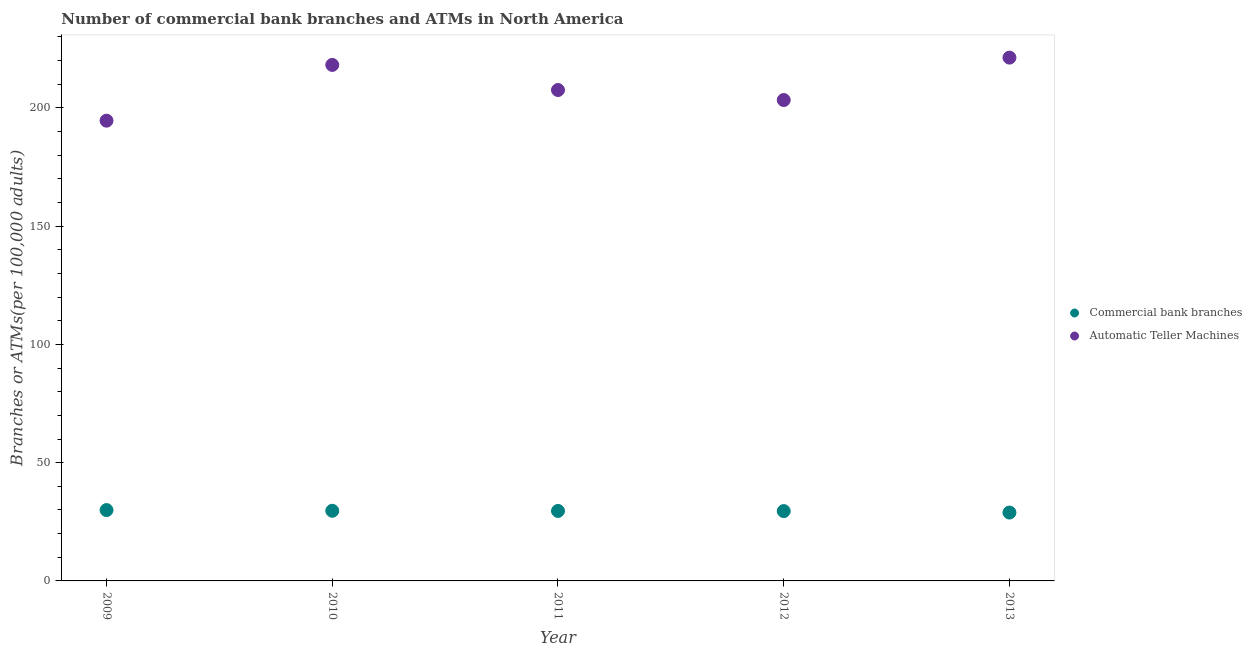What is the number of commercal bank branches in 2011?
Give a very brief answer. 29.59. Across all years, what is the maximum number of atms?
Make the answer very short. 221.26. Across all years, what is the minimum number of commercal bank branches?
Your response must be concise. 28.9. What is the total number of commercal bank branches in the graph?
Your response must be concise. 147.63. What is the difference between the number of commercal bank branches in 2009 and that in 2011?
Give a very brief answer. 0.36. What is the difference between the number of atms in 2013 and the number of commercal bank branches in 2009?
Make the answer very short. 191.31. What is the average number of commercal bank branches per year?
Make the answer very short. 29.53. In the year 2009, what is the difference between the number of atms and number of commercal bank branches?
Make the answer very short. 164.65. In how many years, is the number of commercal bank branches greater than 170?
Give a very brief answer. 0. What is the ratio of the number of atms in 2009 to that in 2011?
Provide a short and direct response. 0.94. Is the number of commercal bank branches in 2010 less than that in 2013?
Ensure brevity in your answer.  No. What is the difference between the highest and the second highest number of atms?
Make the answer very short. 3.08. What is the difference between the highest and the lowest number of atms?
Your answer should be very brief. 26.66. Is the number of atms strictly greater than the number of commercal bank branches over the years?
Keep it short and to the point. Yes. Is the number of commercal bank branches strictly less than the number of atms over the years?
Give a very brief answer. Yes. How many years are there in the graph?
Give a very brief answer. 5. What is the difference between two consecutive major ticks on the Y-axis?
Give a very brief answer. 50. Are the values on the major ticks of Y-axis written in scientific E-notation?
Your answer should be compact. No. Does the graph contain any zero values?
Your answer should be very brief. No. Where does the legend appear in the graph?
Give a very brief answer. Center right. How are the legend labels stacked?
Ensure brevity in your answer.  Vertical. What is the title of the graph?
Your answer should be compact. Number of commercial bank branches and ATMs in North America. What is the label or title of the X-axis?
Your answer should be very brief. Year. What is the label or title of the Y-axis?
Make the answer very short. Branches or ATMs(per 100,0 adults). What is the Branches or ATMs(per 100,000 adults) of Commercial bank branches in 2009?
Ensure brevity in your answer.  29.95. What is the Branches or ATMs(per 100,000 adults) in Automatic Teller Machines in 2009?
Give a very brief answer. 194.6. What is the Branches or ATMs(per 100,000 adults) of Commercial bank branches in 2010?
Your response must be concise. 29.65. What is the Branches or ATMs(per 100,000 adults) of Automatic Teller Machines in 2010?
Ensure brevity in your answer.  218.18. What is the Branches or ATMs(per 100,000 adults) in Commercial bank branches in 2011?
Provide a short and direct response. 29.59. What is the Branches or ATMs(per 100,000 adults) of Automatic Teller Machines in 2011?
Your response must be concise. 207.56. What is the Branches or ATMs(per 100,000 adults) of Commercial bank branches in 2012?
Ensure brevity in your answer.  29.53. What is the Branches or ATMs(per 100,000 adults) of Automatic Teller Machines in 2012?
Keep it short and to the point. 203.33. What is the Branches or ATMs(per 100,000 adults) in Commercial bank branches in 2013?
Provide a short and direct response. 28.9. What is the Branches or ATMs(per 100,000 adults) of Automatic Teller Machines in 2013?
Provide a succinct answer. 221.26. Across all years, what is the maximum Branches or ATMs(per 100,000 adults) of Commercial bank branches?
Ensure brevity in your answer.  29.95. Across all years, what is the maximum Branches or ATMs(per 100,000 adults) in Automatic Teller Machines?
Keep it short and to the point. 221.26. Across all years, what is the minimum Branches or ATMs(per 100,000 adults) of Commercial bank branches?
Give a very brief answer. 28.9. Across all years, what is the minimum Branches or ATMs(per 100,000 adults) of Automatic Teller Machines?
Give a very brief answer. 194.6. What is the total Branches or ATMs(per 100,000 adults) of Commercial bank branches in the graph?
Give a very brief answer. 147.63. What is the total Branches or ATMs(per 100,000 adults) of Automatic Teller Machines in the graph?
Make the answer very short. 1044.92. What is the difference between the Branches or ATMs(per 100,000 adults) in Commercial bank branches in 2009 and that in 2010?
Offer a very short reply. 0.3. What is the difference between the Branches or ATMs(per 100,000 adults) of Automatic Teller Machines in 2009 and that in 2010?
Give a very brief answer. -23.58. What is the difference between the Branches or ATMs(per 100,000 adults) of Commercial bank branches in 2009 and that in 2011?
Provide a succinct answer. 0.36. What is the difference between the Branches or ATMs(per 100,000 adults) of Automatic Teller Machines in 2009 and that in 2011?
Provide a short and direct response. -12.96. What is the difference between the Branches or ATMs(per 100,000 adults) of Commercial bank branches in 2009 and that in 2012?
Your answer should be compact. 0.43. What is the difference between the Branches or ATMs(per 100,000 adults) in Automatic Teller Machines in 2009 and that in 2012?
Keep it short and to the point. -8.73. What is the difference between the Branches or ATMs(per 100,000 adults) in Commercial bank branches in 2009 and that in 2013?
Your answer should be compact. 1.05. What is the difference between the Branches or ATMs(per 100,000 adults) in Automatic Teller Machines in 2009 and that in 2013?
Ensure brevity in your answer.  -26.66. What is the difference between the Branches or ATMs(per 100,000 adults) of Commercial bank branches in 2010 and that in 2011?
Offer a very short reply. 0.06. What is the difference between the Branches or ATMs(per 100,000 adults) of Automatic Teller Machines in 2010 and that in 2011?
Make the answer very short. 10.61. What is the difference between the Branches or ATMs(per 100,000 adults) of Commercial bank branches in 2010 and that in 2012?
Your response must be concise. 0.13. What is the difference between the Branches or ATMs(per 100,000 adults) in Automatic Teller Machines in 2010 and that in 2012?
Keep it short and to the point. 14.85. What is the difference between the Branches or ATMs(per 100,000 adults) of Commercial bank branches in 2010 and that in 2013?
Ensure brevity in your answer.  0.75. What is the difference between the Branches or ATMs(per 100,000 adults) of Automatic Teller Machines in 2010 and that in 2013?
Provide a succinct answer. -3.08. What is the difference between the Branches or ATMs(per 100,000 adults) in Commercial bank branches in 2011 and that in 2012?
Your answer should be compact. 0.06. What is the difference between the Branches or ATMs(per 100,000 adults) in Automatic Teller Machines in 2011 and that in 2012?
Keep it short and to the point. 4.24. What is the difference between the Branches or ATMs(per 100,000 adults) of Commercial bank branches in 2011 and that in 2013?
Offer a terse response. 0.69. What is the difference between the Branches or ATMs(per 100,000 adults) of Automatic Teller Machines in 2011 and that in 2013?
Make the answer very short. -13.7. What is the difference between the Branches or ATMs(per 100,000 adults) in Commercial bank branches in 2012 and that in 2013?
Provide a succinct answer. 0.63. What is the difference between the Branches or ATMs(per 100,000 adults) of Automatic Teller Machines in 2012 and that in 2013?
Give a very brief answer. -17.93. What is the difference between the Branches or ATMs(per 100,000 adults) of Commercial bank branches in 2009 and the Branches or ATMs(per 100,000 adults) of Automatic Teller Machines in 2010?
Provide a short and direct response. -188.22. What is the difference between the Branches or ATMs(per 100,000 adults) of Commercial bank branches in 2009 and the Branches or ATMs(per 100,000 adults) of Automatic Teller Machines in 2011?
Keep it short and to the point. -177.61. What is the difference between the Branches or ATMs(per 100,000 adults) in Commercial bank branches in 2009 and the Branches or ATMs(per 100,000 adults) in Automatic Teller Machines in 2012?
Your answer should be very brief. -173.37. What is the difference between the Branches or ATMs(per 100,000 adults) in Commercial bank branches in 2009 and the Branches or ATMs(per 100,000 adults) in Automatic Teller Machines in 2013?
Give a very brief answer. -191.31. What is the difference between the Branches or ATMs(per 100,000 adults) in Commercial bank branches in 2010 and the Branches or ATMs(per 100,000 adults) in Automatic Teller Machines in 2011?
Provide a succinct answer. -177.91. What is the difference between the Branches or ATMs(per 100,000 adults) of Commercial bank branches in 2010 and the Branches or ATMs(per 100,000 adults) of Automatic Teller Machines in 2012?
Give a very brief answer. -173.67. What is the difference between the Branches or ATMs(per 100,000 adults) of Commercial bank branches in 2010 and the Branches or ATMs(per 100,000 adults) of Automatic Teller Machines in 2013?
Provide a succinct answer. -191.61. What is the difference between the Branches or ATMs(per 100,000 adults) in Commercial bank branches in 2011 and the Branches or ATMs(per 100,000 adults) in Automatic Teller Machines in 2012?
Give a very brief answer. -173.74. What is the difference between the Branches or ATMs(per 100,000 adults) of Commercial bank branches in 2011 and the Branches or ATMs(per 100,000 adults) of Automatic Teller Machines in 2013?
Ensure brevity in your answer.  -191.67. What is the difference between the Branches or ATMs(per 100,000 adults) of Commercial bank branches in 2012 and the Branches or ATMs(per 100,000 adults) of Automatic Teller Machines in 2013?
Your response must be concise. -191.73. What is the average Branches or ATMs(per 100,000 adults) in Commercial bank branches per year?
Give a very brief answer. 29.53. What is the average Branches or ATMs(per 100,000 adults) in Automatic Teller Machines per year?
Your answer should be very brief. 208.98. In the year 2009, what is the difference between the Branches or ATMs(per 100,000 adults) in Commercial bank branches and Branches or ATMs(per 100,000 adults) in Automatic Teller Machines?
Provide a short and direct response. -164.65. In the year 2010, what is the difference between the Branches or ATMs(per 100,000 adults) in Commercial bank branches and Branches or ATMs(per 100,000 adults) in Automatic Teller Machines?
Give a very brief answer. -188.52. In the year 2011, what is the difference between the Branches or ATMs(per 100,000 adults) of Commercial bank branches and Branches or ATMs(per 100,000 adults) of Automatic Teller Machines?
Offer a very short reply. -177.97. In the year 2012, what is the difference between the Branches or ATMs(per 100,000 adults) in Commercial bank branches and Branches or ATMs(per 100,000 adults) in Automatic Teller Machines?
Give a very brief answer. -173.8. In the year 2013, what is the difference between the Branches or ATMs(per 100,000 adults) in Commercial bank branches and Branches or ATMs(per 100,000 adults) in Automatic Teller Machines?
Provide a succinct answer. -192.36. What is the ratio of the Branches or ATMs(per 100,000 adults) in Automatic Teller Machines in 2009 to that in 2010?
Your answer should be very brief. 0.89. What is the ratio of the Branches or ATMs(per 100,000 adults) of Commercial bank branches in 2009 to that in 2011?
Your response must be concise. 1.01. What is the ratio of the Branches or ATMs(per 100,000 adults) in Automatic Teller Machines in 2009 to that in 2011?
Provide a succinct answer. 0.94. What is the ratio of the Branches or ATMs(per 100,000 adults) in Commercial bank branches in 2009 to that in 2012?
Your answer should be very brief. 1.01. What is the ratio of the Branches or ATMs(per 100,000 adults) in Automatic Teller Machines in 2009 to that in 2012?
Your answer should be compact. 0.96. What is the ratio of the Branches or ATMs(per 100,000 adults) in Commercial bank branches in 2009 to that in 2013?
Offer a very short reply. 1.04. What is the ratio of the Branches or ATMs(per 100,000 adults) in Automatic Teller Machines in 2009 to that in 2013?
Provide a short and direct response. 0.88. What is the ratio of the Branches or ATMs(per 100,000 adults) in Commercial bank branches in 2010 to that in 2011?
Provide a succinct answer. 1. What is the ratio of the Branches or ATMs(per 100,000 adults) in Automatic Teller Machines in 2010 to that in 2011?
Give a very brief answer. 1.05. What is the ratio of the Branches or ATMs(per 100,000 adults) of Commercial bank branches in 2010 to that in 2012?
Offer a terse response. 1. What is the ratio of the Branches or ATMs(per 100,000 adults) in Automatic Teller Machines in 2010 to that in 2012?
Keep it short and to the point. 1.07. What is the ratio of the Branches or ATMs(per 100,000 adults) of Automatic Teller Machines in 2010 to that in 2013?
Offer a very short reply. 0.99. What is the ratio of the Branches or ATMs(per 100,000 adults) of Commercial bank branches in 2011 to that in 2012?
Ensure brevity in your answer.  1. What is the ratio of the Branches or ATMs(per 100,000 adults) of Automatic Teller Machines in 2011 to that in 2012?
Provide a succinct answer. 1.02. What is the ratio of the Branches or ATMs(per 100,000 adults) in Commercial bank branches in 2011 to that in 2013?
Offer a very short reply. 1.02. What is the ratio of the Branches or ATMs(per 100,000 adults) in Automatic Teller Machines in 2011 to that in 2013?
Make the answer very short. 0.94. What is the ratio of the Branches or ATMs(per 100,000 adults) of Commercial bank branches in 2012 to that in 2013?
Your answer should be compact. 1.02. What is the ratio of the Branches or ATMs(per 100,000 adults) of Automatic Teller Machines in 2012 to that in 2013?
Give a very brief answer. 0.92. What is the difference between the highest and the second highest Branches or ATMs(per 100,000 adults) in Commercial bank branches?
Give a very brief answer. 0.3. What is the difference between the highest and the second highest Branches or ATMs(per 100,000 adults) of Automatic Teller Machines?
Your answer should be compact. 3.08. What is the difference between the highest and the lowest Branches or ATMs(per 100,000 adults) of Commercial bank branches?
Give a very brief answer. 1.05. What is the difference between the highest and the lowest Branches or ATMs(per 100,000 adults) in Automatic Teller Machines?
Ensure brevity in your answer.  26.66. 